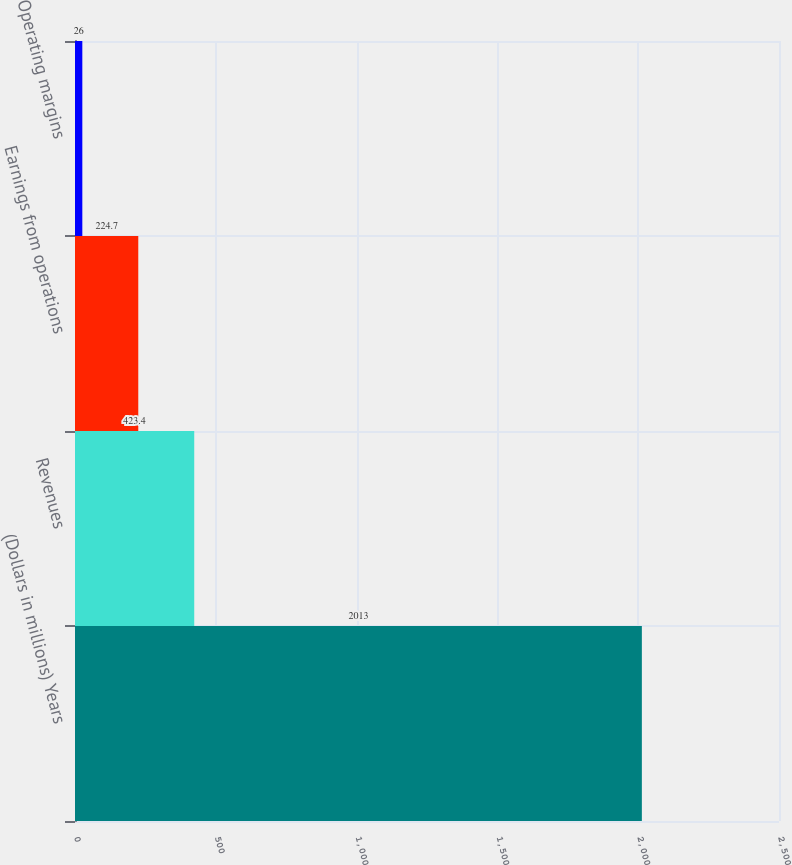Convert chart to OTSL. <chart><loc_0><loc_0><loc_500><loc_500><bar_chart><fcel>(Dollars in millions) Years<fcel>Revenues<fcel>Earnings from operations<fcel>Operating margins<nl><fcel>2013<fcel>423.4<fcel>224.7<fcel>26<nl></chart> 